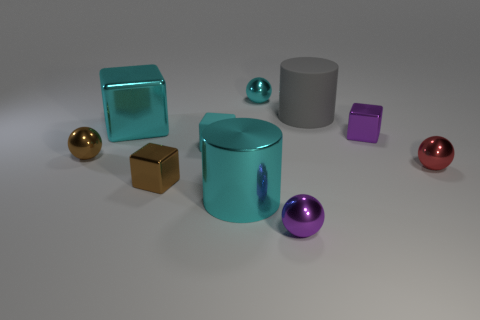Subtract all tiny blocks. How many blocks are left? 1 Subtract all purple blocks. How many blocks are left? 3 Subtract 3 balls. How many balls are left? 1 Subtract 0 gray spheres. How many objects are left? 10 Subtract all balls. How many objects are left? 6 Subtract all cyan blocks. Subtract all gray cylinders. How many blocks are left? 2 Subtract all blue cylinders. How many cyan blocks are left? 2 Subtract all gray rubber things. Subtract all big shiny things. How many objects are left? 7 Add 9 small purple shiny blocks. How many small purple shiny blocks are left? 10 Add 3 tiny red shiny things. How many tiny red shiny things exist? 4 